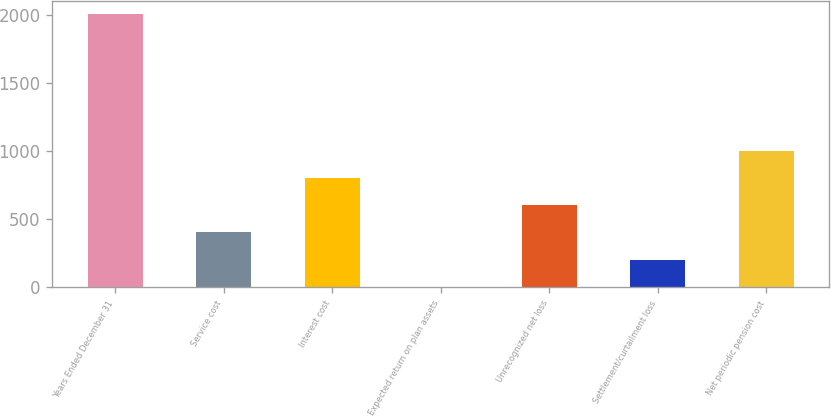Convert chart. <chart><loc_0><loc_0><loc_500><loc_500><bar_chart><fcel>Years Ended December 31<fcel>Service cost<fcel>Interest cost<fcel>Expected return on plan assets<fcel>Unrecognized net loss<fcel>Settlement/curtailment loss<fcel>Net periodic pension cost<nl><fcel>2006<fcel>404.4<fcel>804.8<fcel>4<fcel>604.6<fcel>204.2<fcel>1005<nl></chart> 